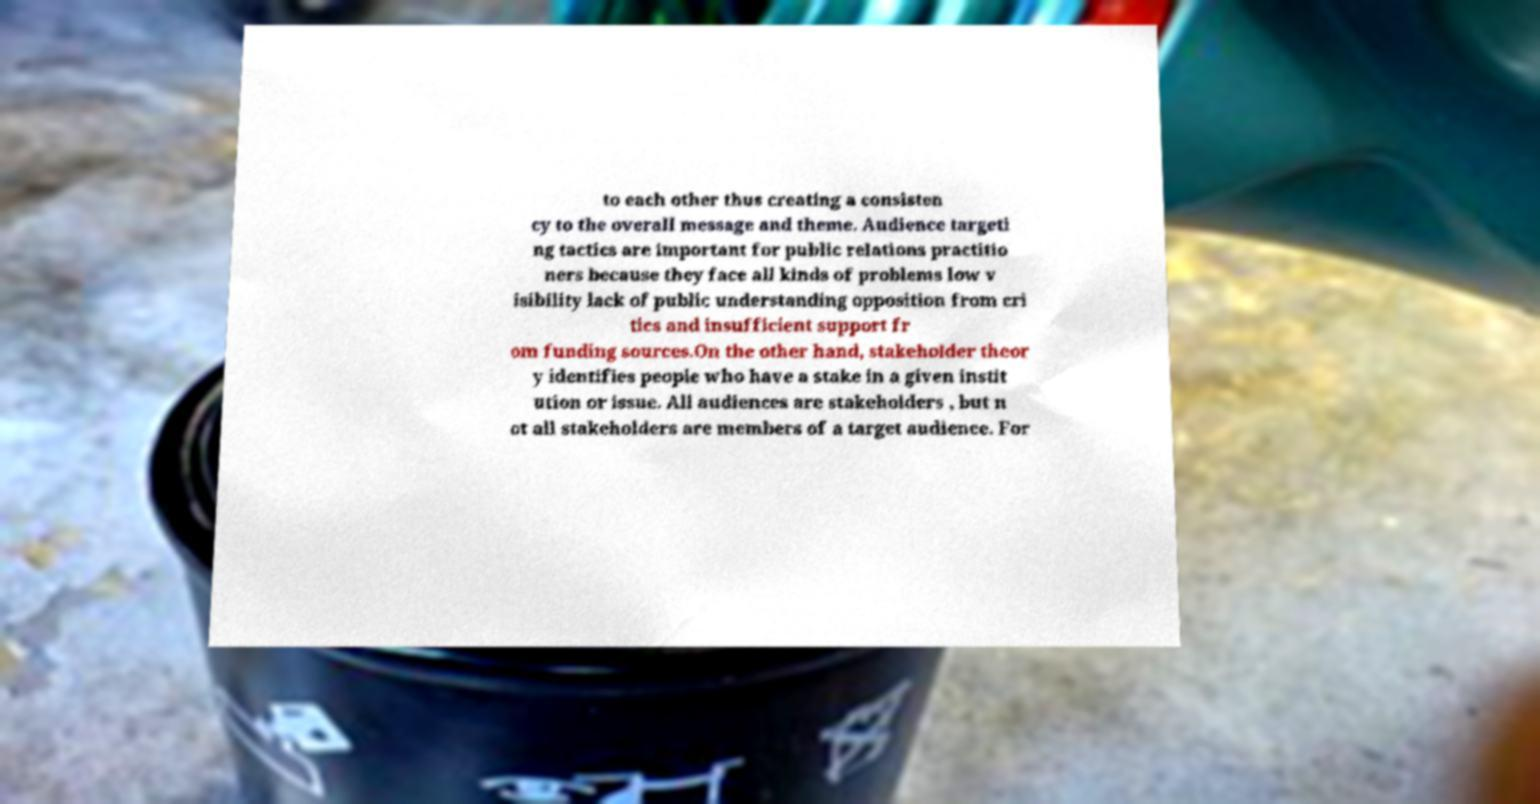Can you read and provide the text displayed in the image?This photo seems to have some interesting text. Can you extract and type it out for me? to each other thus creating a consisten cy to the overall message and theme. Audience targeti ng tactics are important for public relations practitio ners because they face all kinds of problems low v isibility lack of public understanding opposition from cri tics and insufficient support fr om funding sources.On the other hand, stakeholder theor y identifies people who have a stake in a given instit ution or issue. All audiences are stakeholders , but n ot all stakeholders are members of a target audience. For 